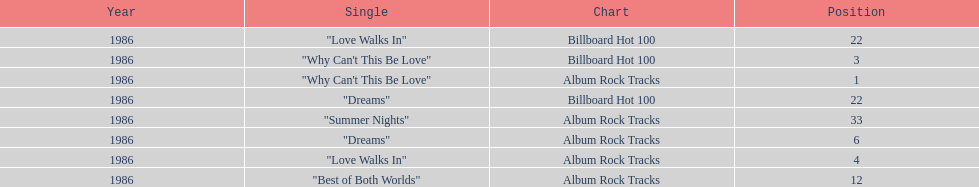Which is the most popular single on the album? Why Can't This Be Love. 